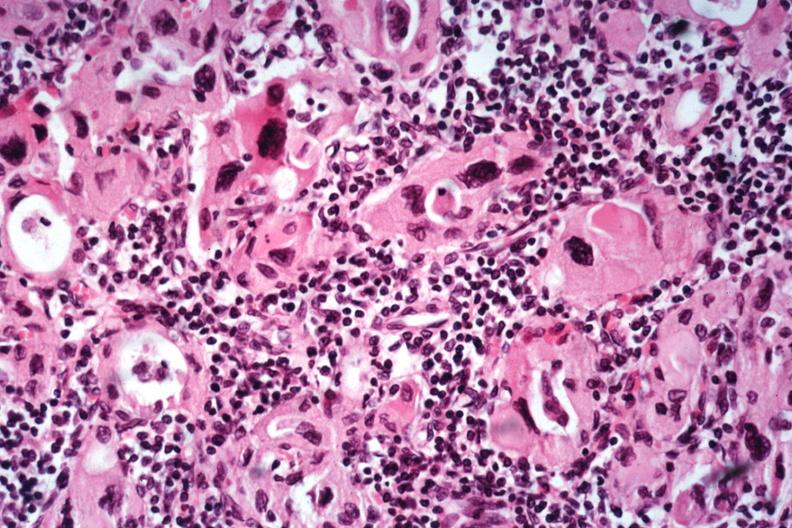s endocrine present?
Answer the question using a single word or phrase. Yes 